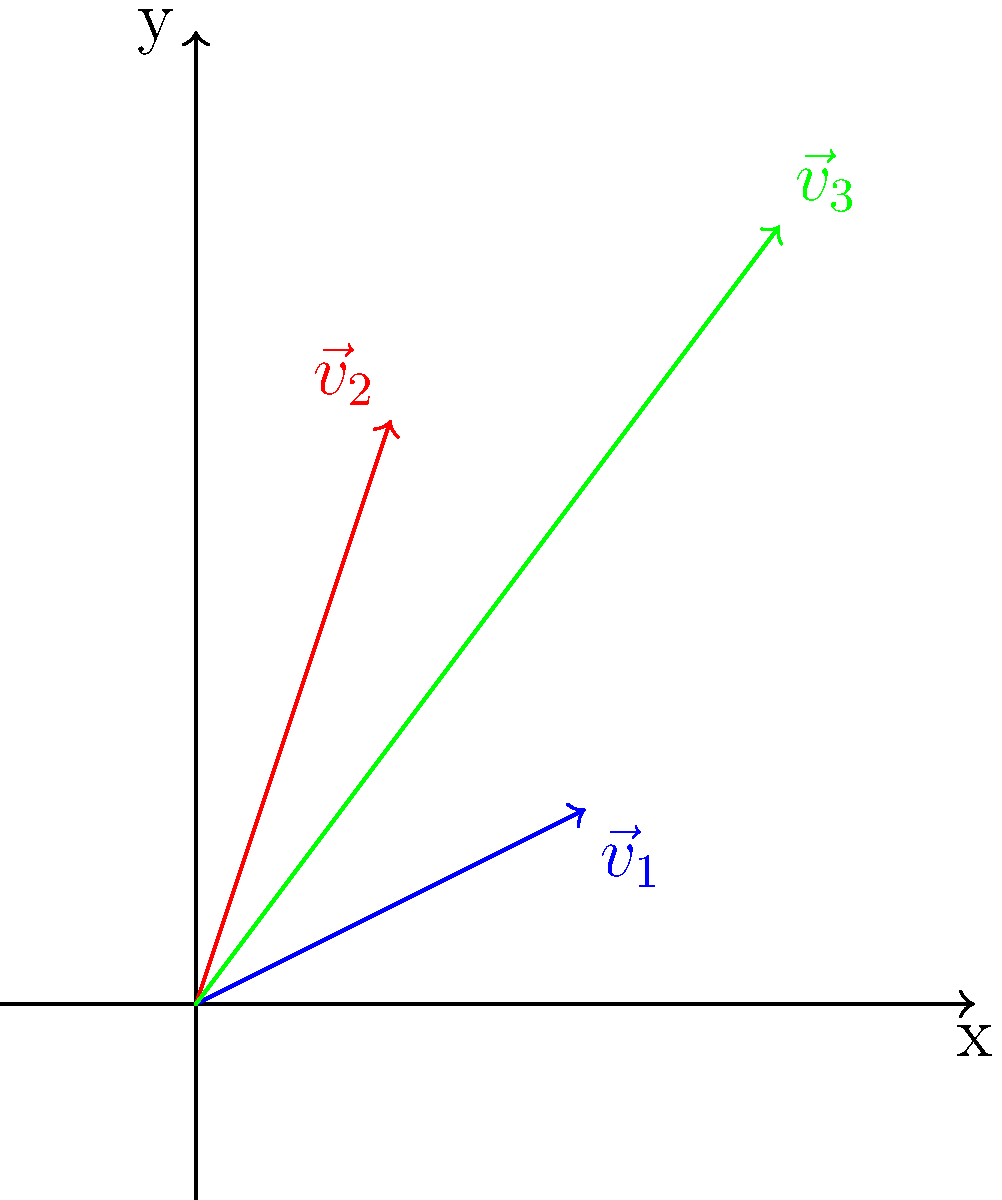In modeling protein folding pathways, we often represent amino acid interactions as vectors. Consider the vector diagram above, where $\vec{v}_1$ and $\vec{v}_2$ represent two different amino acid interactions. If $\vec{v}_3$ is the resultant vector of $\vec{v}_1$ and $\vec{v}_2$, what does this combined interaction suggest about the protein's folding behavior, and how can this information be used to enhance the biology department's approach to teaching protein structure? To answer this question, let's break it down step-by-step:

1. Vector representation: 
   $\vec{v}_1 = (2,1)$, $\vec{v}_2 = (1,3)$, and $\vec{v}_3 = \vec{v}_1 + \vec{v}_2 = (3,4)$

2. Meaning of vectors:
   - $\vec{v}_1$ and $\vec{v}_2$ represent individual amino acid interactions
   - $\vec{v}_3$ represents the combined effect of these interactions

3. Interpretation of the resultant vector:
   - The magnitude of $\vec{v}_3$ ($\sqrt{3^2 + 4^2} = 5$) is greater than either $\vec{v}_1$ or $\vec{v}_2$, suggesting a stronger overall interaction
   - The direction of $\vec{v}_3$ indicates the net direction of the protein fold in this region

4. Implications for protein folding:
   - The combined interaction ($\vec{v}_3$) suggests a cooperative effect between the two amino acid interactions
   - This cooperation likely contributes to the stability of a particular fold or structural motif

5. Application to teaching:
   - Use this vector model to visually demonstrate how multiple weak interactions can lead to stronger, directed folding patterns
   - Emphasize the importance of considering multiple interactions simultaneously, rather than in isolation
   - Introduce computational modeling techniques that use vector representations to predict protein structures

6. Innovative teaching approaches:
   - Develop interactive simulations where students can manipulate vectors to see how changes in individual interactions affect the overall protein structure
   - Create hands-on activities using physical vector models to represent amino acid interactions
   - Integrate this vector-based approach with traditional biochemistry lessons to provide a more comprehensive understanding of protein structure and function
Answer: The resultant vector suggests cooperative amino acid interactions that likely stabilize a specific protein fold, providing a visual tool for teaching complex protein structure formation through vector addition and analysis. 